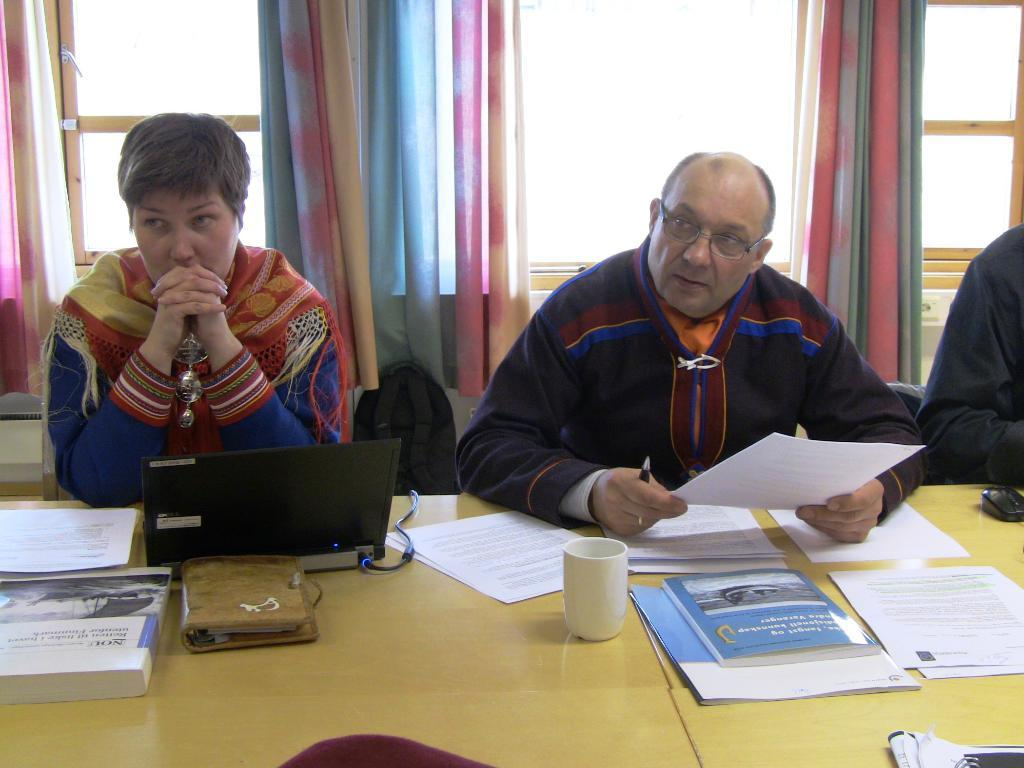What type of openings can be seen in the image? There are windows in the image. What type of window treatment is present in the image? There are curtains in the image. What are the people in the image doing? The people are sitting on chairs in the image. What object is present in the image that might be used for carrying items? There is a bag in the image. What type of furniture is present in the image? There is a table in the image. What items can be seen on the table? There are papers, a book, a glass, a laptop, and a wallet on the table. What type of tool is being used for teaching in the image? There is no tool or teaching activity depicted in the image. What type of scene is being portrayed in the image? The image does not depict a specific scene; it shows a table with various objects and people sitting on chairs. 